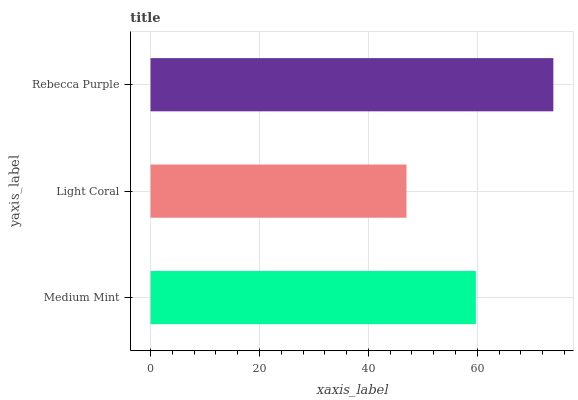Is Light Coral the minimum?
Answer yes or no. Yes. Is Rebecca Purple the maximum?
Answer yes or no. Yes. Is Rebecca Purple the minimum?
Answer yes or no. No. Is Light Coral the maximum?
Answer yes or no. No. Is Rebecca Purple greater than Light Coral?
Answer yes or no. Yes. Is Light Coral less than Rebecca Purple?
Answer yes or no. Yes. Is Light Coral greater than Rebecca Purple?
Answer yes or no. No. Is Rebecca Purple less than Light Coral?
Answer yes or no. No. Is Medium Mint the high median?
Answer yes or no. Yes. Is Medium Mint the low median?
Answer yes or no. Yes. Is Rebecca Purple the high median?
Answer yes or no. No. Is Rebecca Purple the low median?
Answer yes or no. No. 